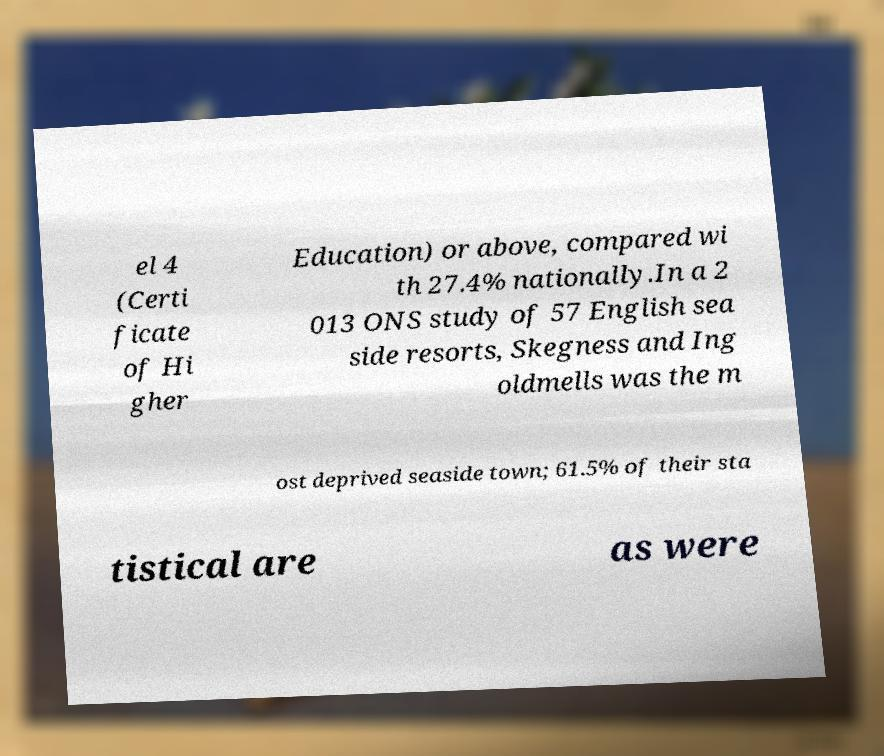For documentation purposes, I need the text within this image transcribed. Could you provide that? el 4 (Certi ficate of Hi gher Education) or above, compared wi th 27.4% nationally.In a 2 013 ONS study of 57 English sea side resorts, Skegness and Ing oldmells was the m ost deprived seaside town; 61.5% of their sta tistical are as were 